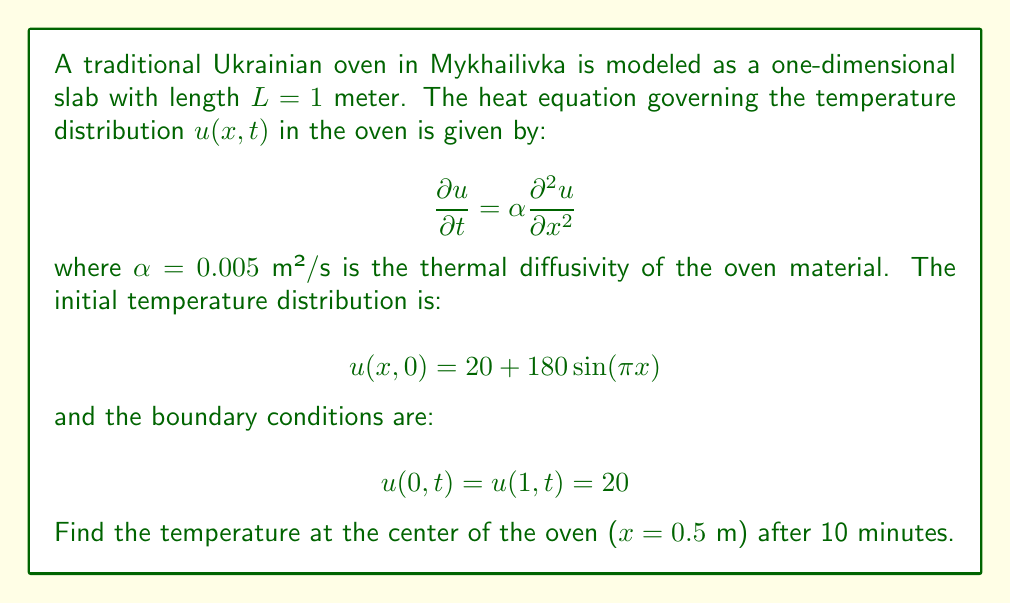Provide a solution to this math problem. To solve this problem, we'll use the method of separation of variables.

1) Assume a solution of the form: $u(x,t) = X(x)T(t)$

2) Substituting into the heat equation:
   $$X(x)T'(t) = \alpha X''(x)T(t)$$
   $$\frac{T'(t)}{αT(t)} = \frac{X''(x)}{X(x)} = -λ^2$$

3) This gives us two equations:
   $$T'(t) + αλ^2T(t) = 0$$
   $$X''(x) + λ^2X(x) = 0$$

4) The general solutions are:
   $$T(t) = Ce^{-αλ^2t}$$
   $$X(x) = A\sin(λx) + B\cos(λx)$$

5) Applying the boundary conditions:
   $$X(0) = X(1) = 0$$
   This gives us $λ_n = nπ$ for $n = 1,2,3,...$

6) The general solution is:
   $$u(x,t) = \sum_{n=1}^{\infty} A_n \sin(nπx)e^{-αn^2π^2t}$$

7) To find $A_n$, we use the initial condition:
   $$20 + 180\sin(πx) = \sum_{n=1}^{\infty} A_n \sin(nπx)$$

8) This implies $A_1 = 180$ and $A_n = 0$ for $n > 1$

9) Therefore, the solution is:
   $$u(x,t) = 20 + 180\sin(πx)e^{-απ^2t}$$

10) At the center (x = 0.5) after 10 minutes (t = 600 s):
    $$u(0.5, 600) = 20 + 180\sin(π/2)e^{-0.005π^2(600)}$$

11) Calculating:
    $$u(0.5, 600) = 20 + 180e^{-0.005π^2(600)} ≈ 20 + 180(0.0878) ≈ 35.8°C$$
Answer: The temperature at the center of the oven after 10 minutes is approximately 35.8°C. 